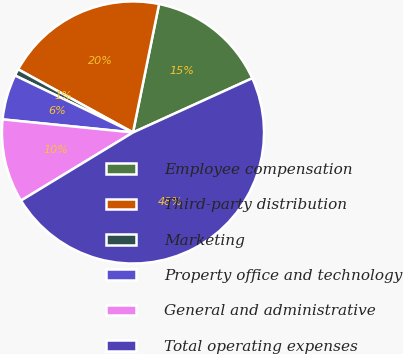Convert chart. <chart><loc_0><loc_0><loc_500><loc_500><pie_chart><fcel>Employee compensation<fcel>Third-party distribution<fcel>Marketing<fcel>Property office and technology<fcel>General and administrative<fcel>Total operating expenses<nl><fcel>15.02%<fcel>20.19%<fcel>0.84%<fcel>5.57%<fcel>10.29%<fcel>48.1%<nl></chart> 